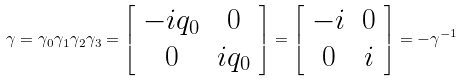Convert formula to latex. <formula><loc_0><loc_0><loc_500><loc_500>\gamma = \gamma _ { 0 } \gamma _ { 1 } \gamma _ { 2 } \gamma _ { 3 } = \left [ \begin{array} { c c } - i q _ { 0 } & 0 \\ 0 & i q _ { 0 } \end{array} \right ] = \left [ \begin{array} { c c } - i & 0 \\ 0 & i \end{array} \right ] = - \gamma ^ { - 1 }</formula> 